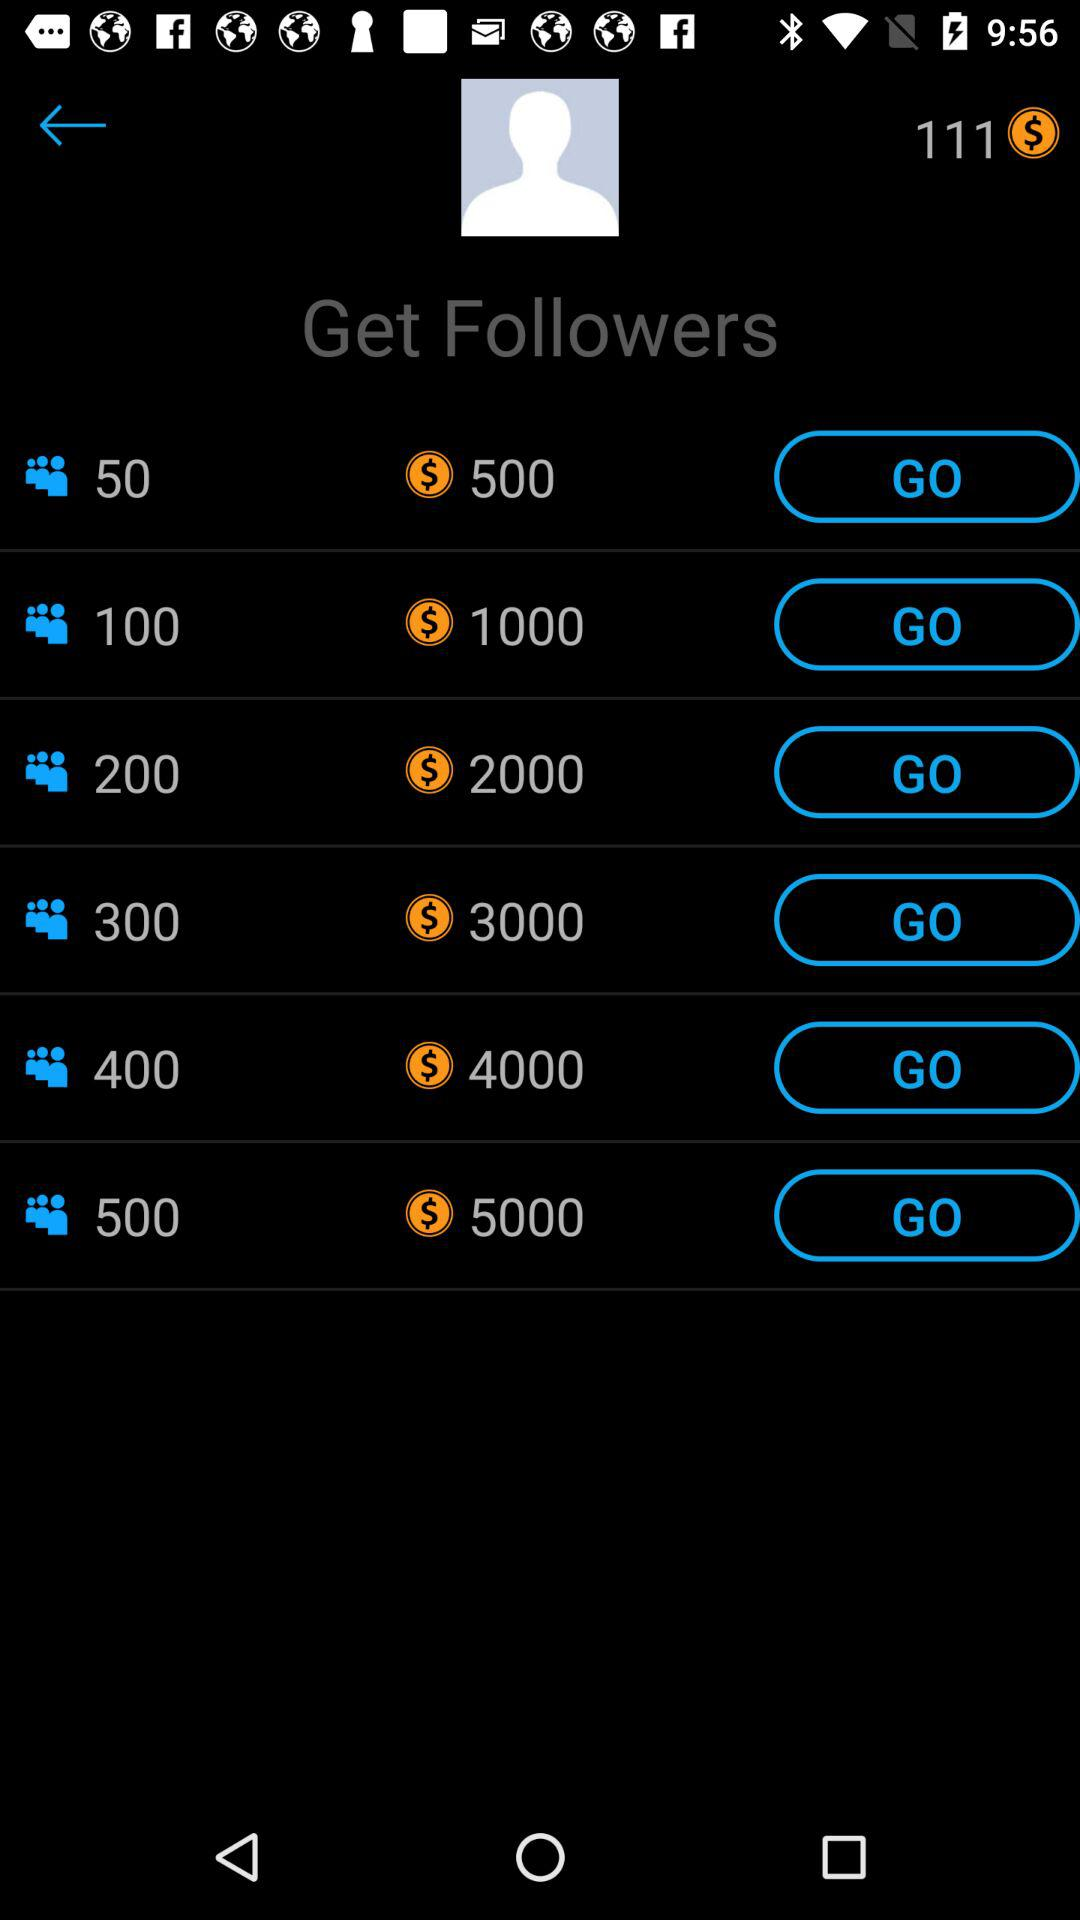What is the balance? The balance is $111. 